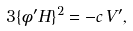Convert formula to latex. <formula><loc_0><loc_0><loc_500><loc_500>3 \{ \phi ^ { \prime } H \} ^ { 2 } = - c \, V ^ { \prime } ,</formula> 